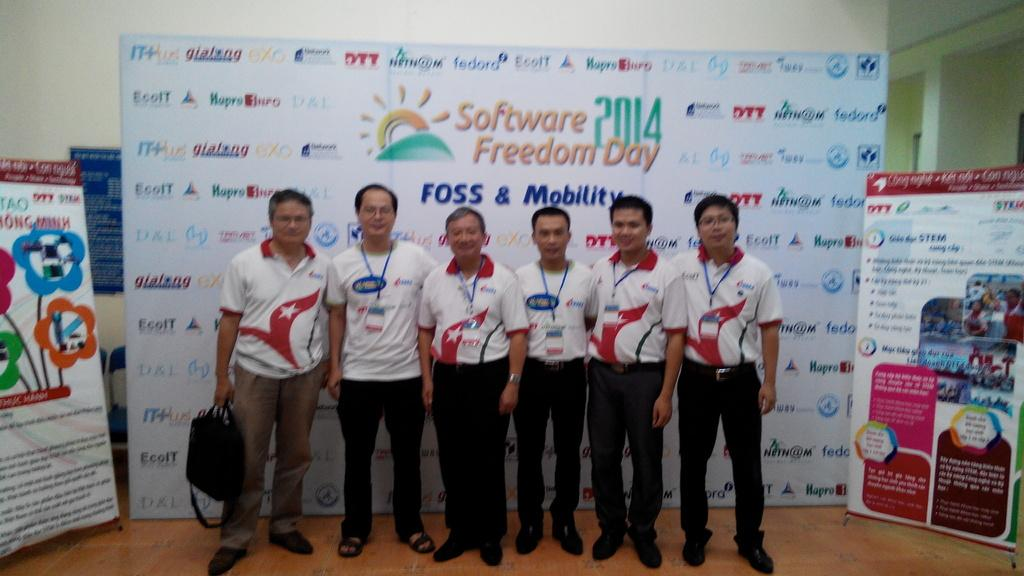<image>
Present a compact description of the photo's key features. people standing in front of a big sign saying Software 2014 Freedom Day 